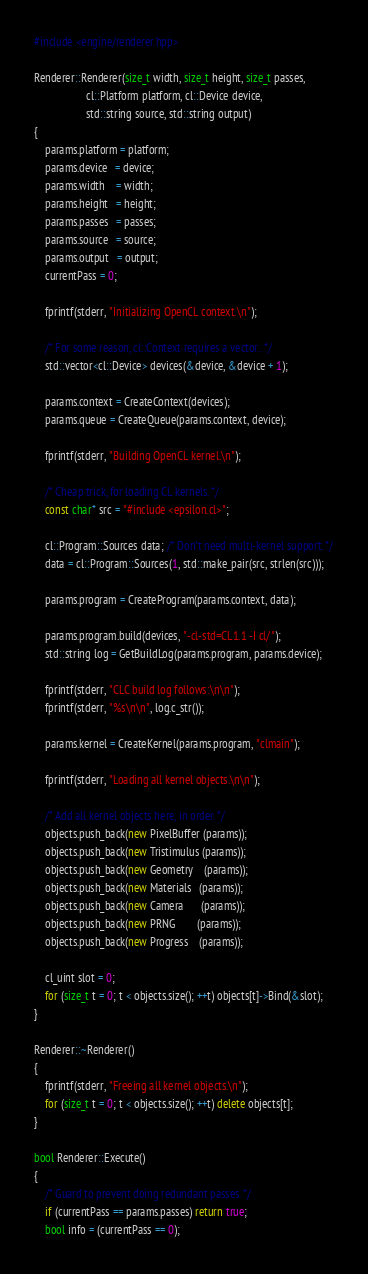Convert code to text. <code><loc_0><loc_0><loc_500><loc_500><_C++_>#include <engine/renderer.hpp>

Renderer::Renderer(size_t width, size_t height, size_t passes,
                   cl::Platform platform, cl::Device device,
                   std::string source, std::string output)
{
    params.platform = platform;
    params.device   = device;
    params.width    = width;
    params.height   = height;
    params.passes   = passes;
    params.source   = source;
    params.output   = output;
    currentPass = 0;

    fprintf(stderr, "Initializing OpenCL context.\n");

    /* For some reason, cl::Context requires a vector.. */
    std::vector<cl::Device> devices(&device, &device + 1);

    params.context = CreateContext(devices);
    params.queue = CreateQueue(params.context, device);

    fprintf(stderr, "Building OpenCL kernel.\n");

    /* Cheap trick, for loading CL kernels. */
    const char* src = "#include <epsilon.cl>";

    cl::Program::Sources data; /* Don't need multi-kernel support. */
    data = cl::Program::Sources(1, std::make_pair(src, strlen(src)));

    params.program = CreateProgram(params.context, data);

    params.program.build(devices, "-cl-std=CL1.1 -I cl/");
    std::string log = GetBuildLog(params.program, params.device);

    fprintf(stderr, "CLC build log follows:\n\n");
    fprintf(stderr, "%s\n\n", log.c_str());

    params.kernel = CreateKernel(params.program, "clmain");

    fprintf(stderr, "Loading all kernel objects.\n\n");

    /* Add all kernel objects here, in order. */
    objects.push_back(new PixelBuffer (params));
    objects.push_back(new Tristimulus (params));
    objects.push_back(new Geometry    (params));
    objects.push_back(new Materials   (params));
    objects.push_back(new Camera      (params));
    objects.push_back(new PRNG        (params));
    objects.push_back(new Progress    (params));

    cl_uint slot = 0;
    for (size_t t = 0; t < objects.size(); ++t) objects[t]->Bind(&slot);
}

Renderer::~Renderer()
{
    fprintf(stderr, "Freeing all kernel objects.\n");
    for (size_t t = 0; t < objects.size(); ++t) delete objects[t];
}

bool Renderer::Execute()
{
    /* Guard to prevent doing redundant passes. */
    if (currentPass == params.passes) return true;
    bool info = (currentPass == 0);</code> 